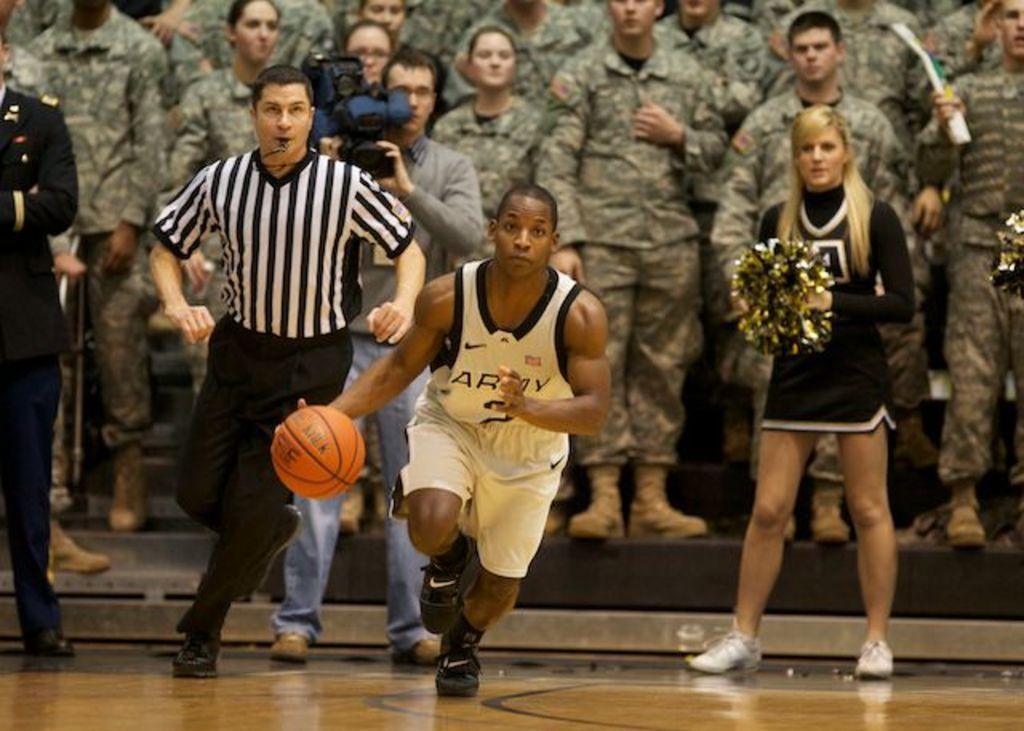How would you summarize this image in a sentence or two? In the center of the image there is a person running with basketball on the ground. In the background we can see referee, cameraman, cheer girls and persons. 